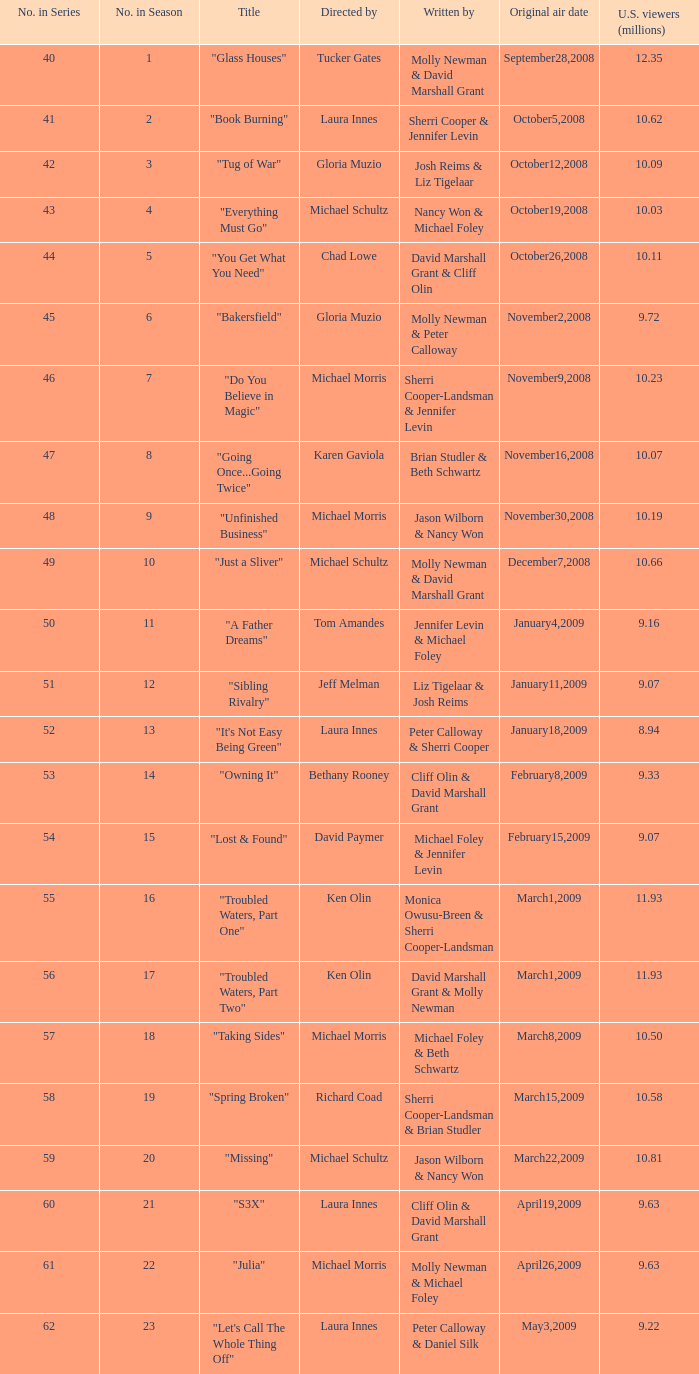What's the appellation of the episode witnessed by "S3X". 